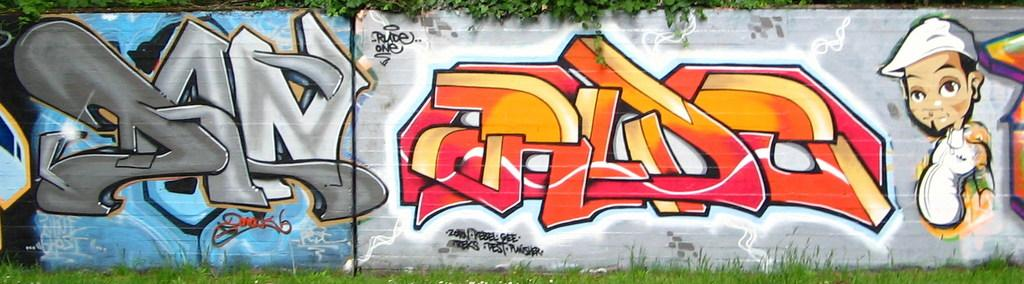What type of vegetation is at the bottom of the image? There is grass at the bottom of the image. What can be seen in the middle of the image? There is a painting on the wall in the middle of the image. What color are the leaves at the top of the image? The leaves at the top of the image are green in color. Where is the lumber being stored in the image? There is no lumber present in the image. What type of development is taking place in the image? There is no development taking place in the image; it primarily features a painting, grass, and leaves. 